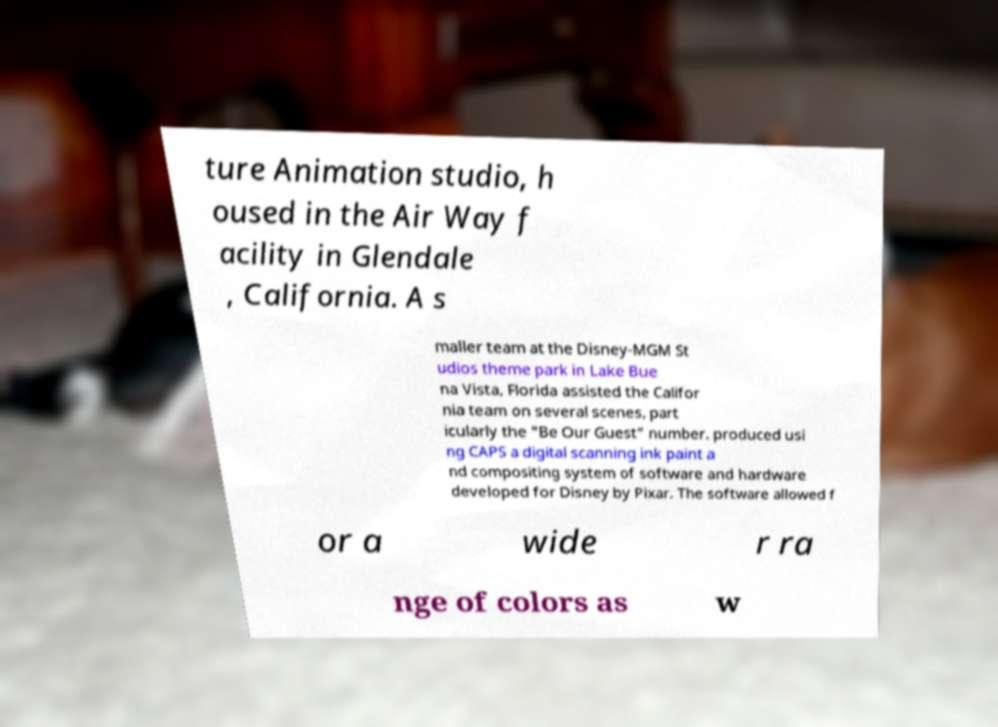I need the written content from this picture converted into text. Can you do that? ture Animation studio, h oused in the Air Way f acility in Glendale , California. A s maller team at the Disney-MGM St udios theme park in Lake Bue na Vista, Florida assisted the Califor nia team on several scenes, part icularly the "Be Our Guest" number. produced usi ng CAPS a digital scanning ink paint a nd compositing system of software and hardware developed for Disney by Pixar. The software allowed f or a wide r ra nge of colors as w 